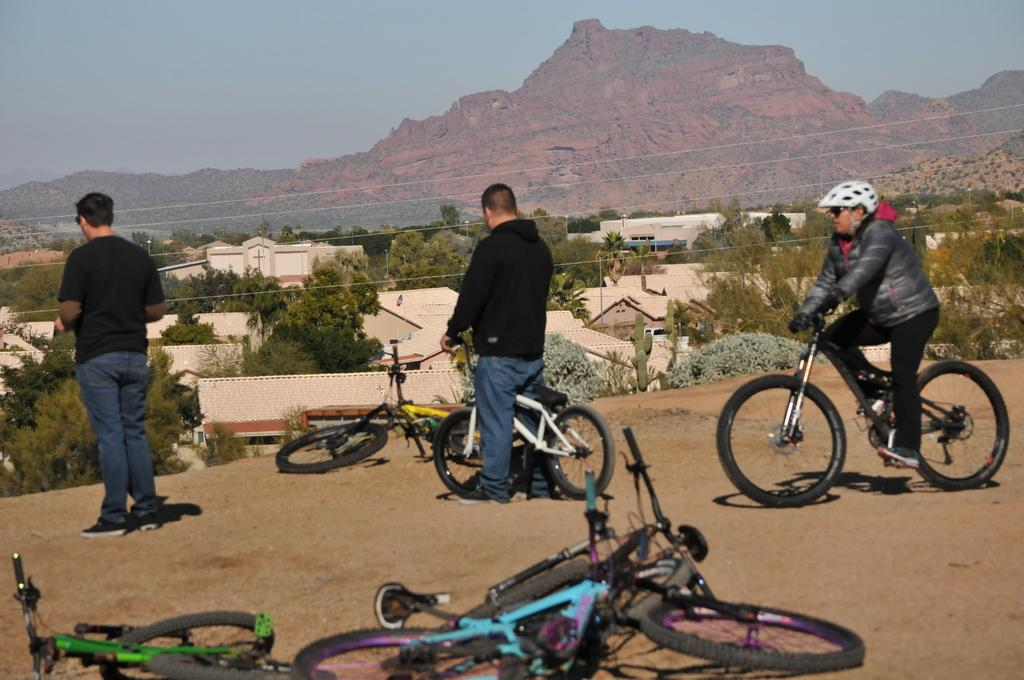What is the man on the left side of the image doing? There is a man standing on the left side of the image. What is the man in the middle of the image holding? There is a man holding a bicycle in the middle of the image. What is the man on the right side of the image doing? There is a man riding a bicycle on the right side of the image. What can be seen in the background of the image? There are hills visible at the top of the image. What type of horse is the manager riding in the image? There is no horse or manager present in the image. How many times does the man on the right side of the image sneeze in the image? There is no sneezing depicted in the image; the man is riding a bicycle. 